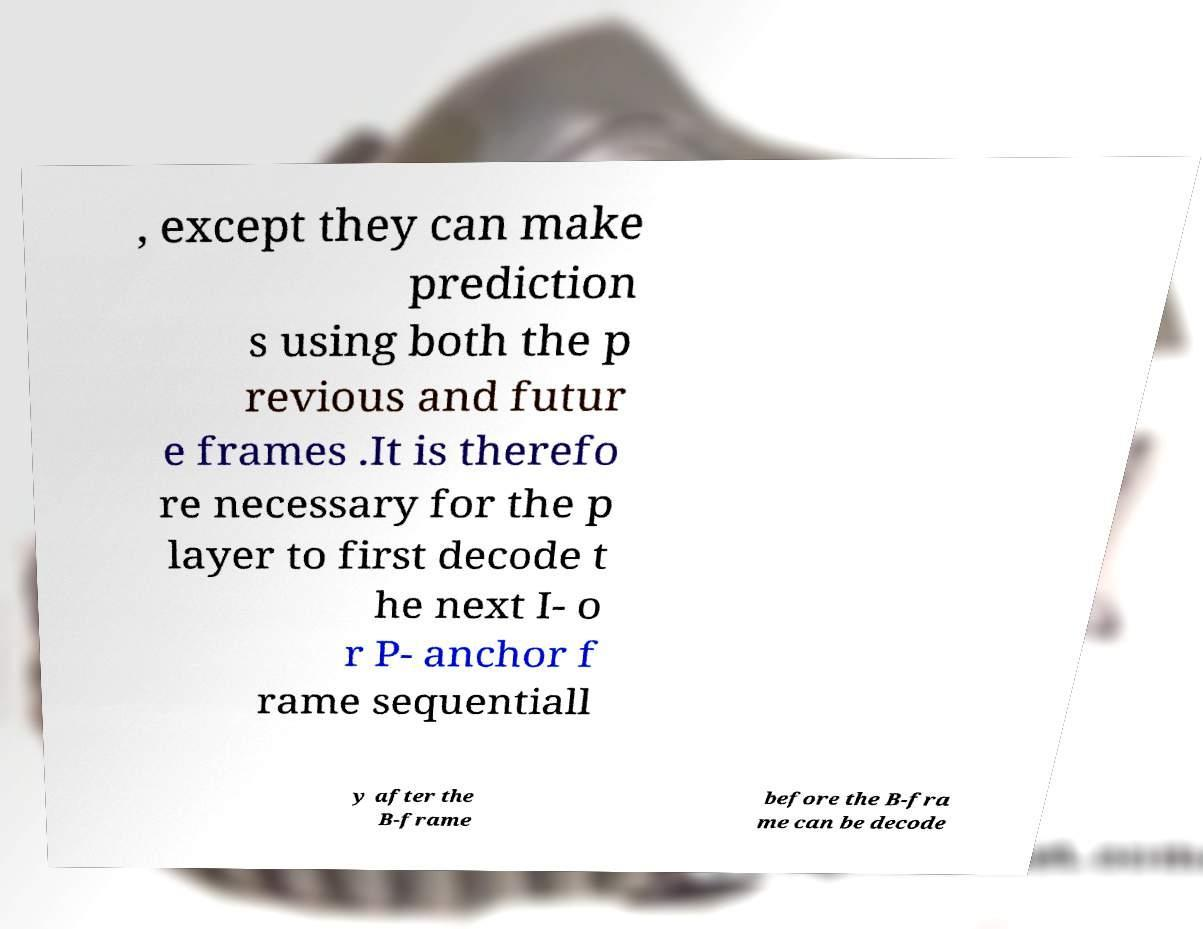I need the written content from this picture converted into text. Can you do that? , except they can make prediction s using both the p revious and futur e frames .It is therefo re necessary for the p layer to first decode t he next I- o r P- anchor f rame sequentiall y after the B-frame before the B-fra me can be decode 